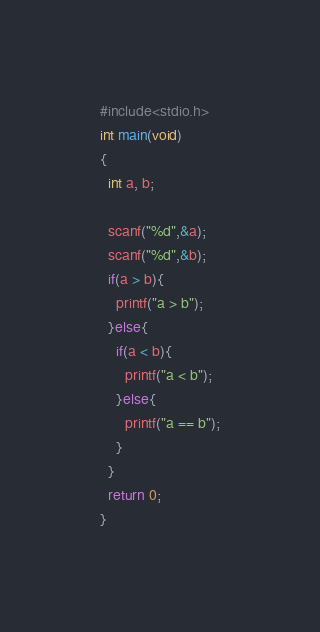Convert code to text. <code><loc_0><loc_0><loc_500><loc_500><_C_>#include<stdio.h>
int main(void)
{
  int a, b;

  scanf("%d",&a);
  scanf("%d",&b);
  if(a > b){
    printf("a > b");
  }else{
    if(a < b){
      printf("a < b");
    }else{
      printf("a == b");
    }
  }
  return 0;
}</code> 